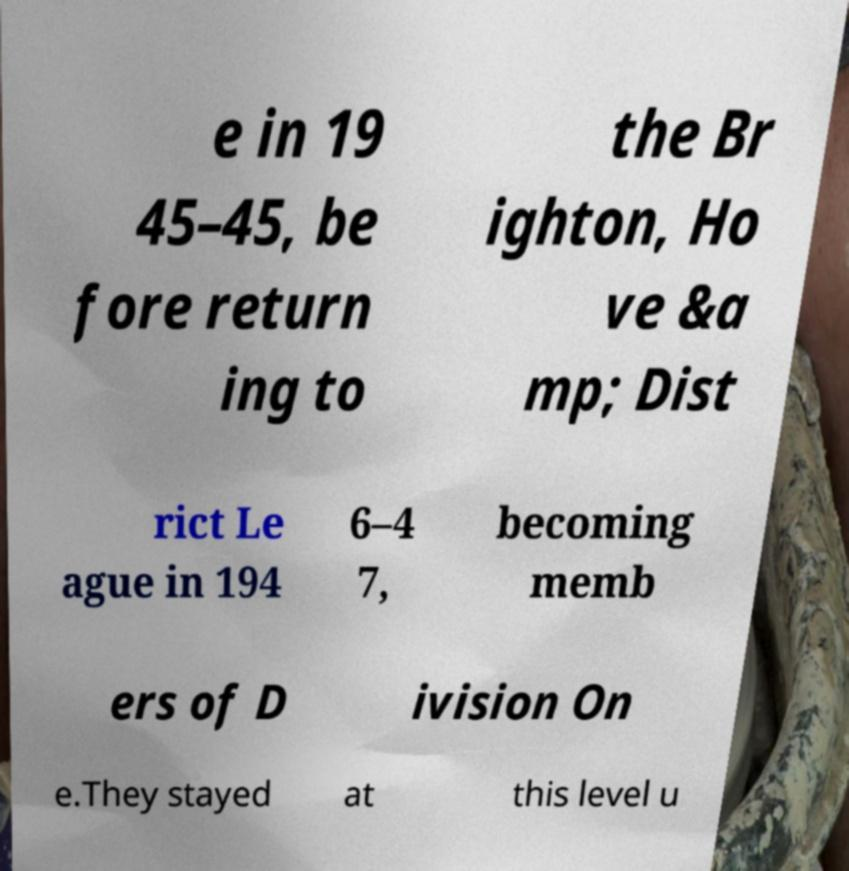Can you read and provide the text displayed in the image?This photo seems to have some interesting text. Can you extract and type it out for me? e in 19 45–45, be fore return ing to the Br ighton, Ho ve &a mp; Dist rict Le ague in 194 6–4 7, becoming memb ers of D ivision On e.They stayed at this level u 